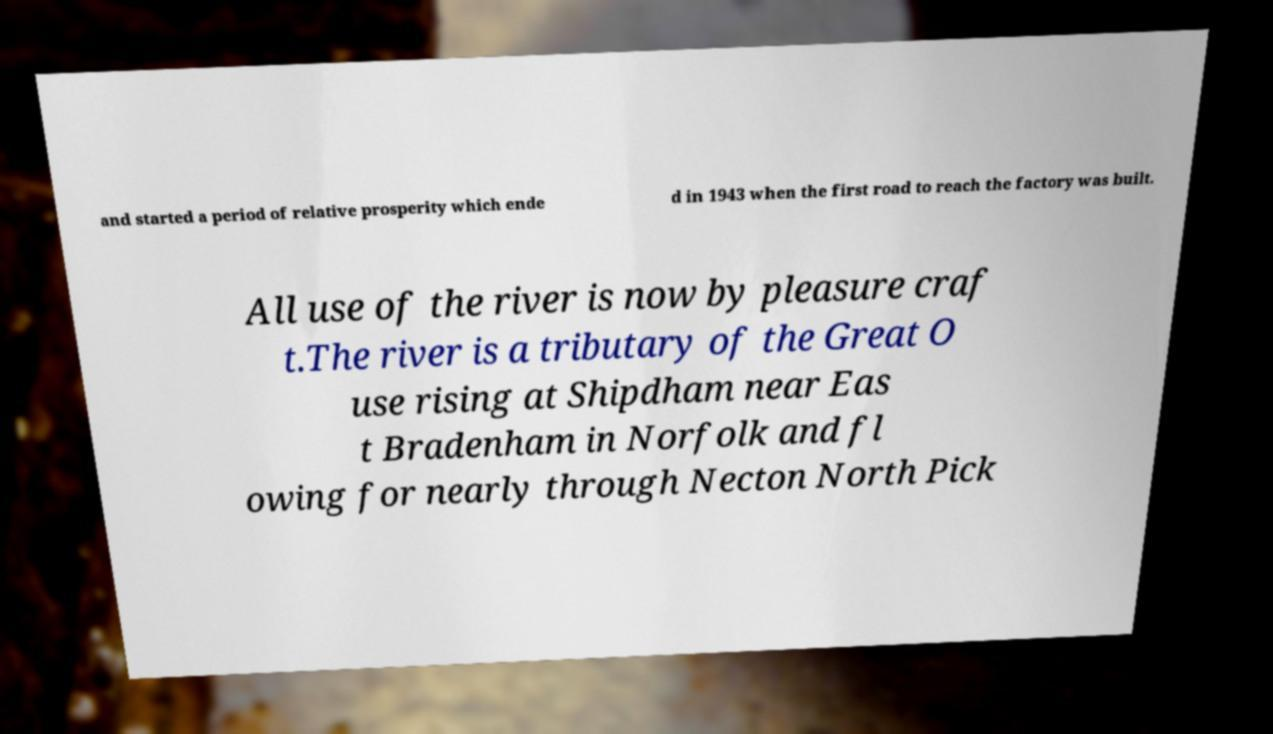Please read and relay the text visible in this image. What does it say? and started a period of relative prosperity which ende d in 1943 when the first road to reach the factory was built. All use of the river is now by pleasure craf t.The river is a tributary of the Great O use rising at Shipdham near Eas t Bradenham in Norfolk and fl owing for nearly through Necton North Pick 